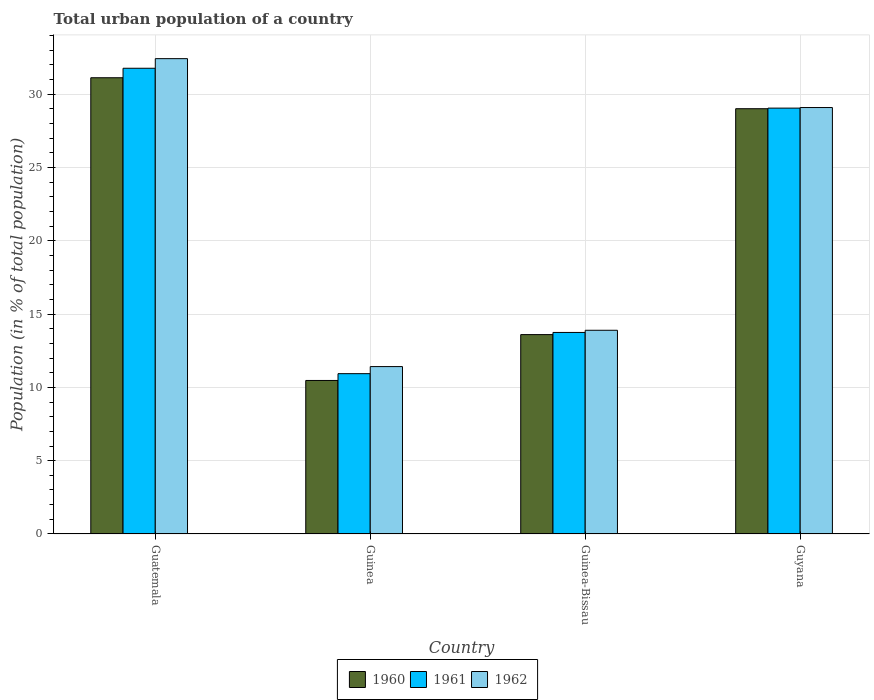How many different coloured bars are there?
Provide a short and direct response. 3. Are the number of bars on each tick of the X-axis equal?
Your response must be concise. Yes. How many bars are there on the 4th tick from the right?
Provide a short and direct response. 3. What is the label of the 3rd group of bars from the left?
Keep it short and to the point. Guinea-Bissau. What is the urban population in 1961 in Guinea?
Offer a very short reply. 10.94. Across all countries, what is the maximum urban population in 1960?
Offer a very short reply. 31.12. Across all countries, what is the minimum urban population in 1961?
Provide a succinct answer. 10.94. In which country was the urban population in 1962 maximum?
Your answer should be very brief. Guatemala. In which country was the urban population in 1962 minimum?
Your response must be concise. Guinea. What is the total urban population in 1962 in the graph?
Your answer should be compact. 86.83. What is the difference between the urban population in 1962 in Guatemala and that in Guinea-Bissau?
Ensure brevity in your answer.  18.53. What is the difference between the urban population in 1961 in Guatemala and the urban population in 1960 in Guinea?
Provide a short and direct response. 21.3. What is the average urban population in 1960 per country?
Give a very brief answer. 21.05. What is the difference between the urban population of/in 1960 and urban population of/in 1962 in Guatemala?
Ensure brevity in your answer.  -1.3. In how many countries, is the urban population in 1961 greater than 10 %?
Make the answer very short. 4. What is the ratio of the urban population in 1960 in Guinea to that in Guinea-Bissau?
Your response must be concise. 0.77. Is the urban population in 1961 in Guinea-Bissau less than that in Guyana?
Your response must be concise. Yes. Is the difference between the urban population in 1960 in Guatemala and Guinea-Bissau greater than the difference between the urban population in 1962 in Guatemala and Guinea-Bissau?
Offer a terse response. No. What is the difference between the highest and the second highest urban population in 1962?
Make the answer very short. 18.53. What is the difference between the highest and the lowest urban population in 1960?
Offer a very short reply. 20.65. What does the 3rd bar from the left in Guatemala represents?
Ensure brevity in your answer.  1962. How many bars are there?
Your answer should be compact. 12. What is the difference between two consecutive major ticks on the Y-axis?
Your answer should be compact. 5. Does the graph contain grids?
Your answer should be very brief. Yes. Where does the legend appear in the graph?
Offer a terse response. Bottom center. How many legend labels are there?
Your answer should be compact. 3. How are the legend labels stacked?
Give a very brief answer. Horizontal. What is the title of the graph?
Your answer should be compact. Total urban population of a country. Does "2004" appear as one of the legend labels in the graph?
Keep it short and to the point. No. What is the label or title of the X-axis?
Ensure brevity in your answer.  Country. What is the label or title of the Y-axis?
Give a very brief answer. Population (in % of total population). What is the Population (in % of total population) in 1960 in Guatemala?
Give a very brief answer. 31.12. What is the Population (in % of total population) in 1961 in Guatemala?
Keep it short and to the point. 31.77. What is the Population (in % of total population) of 1962 in Guatemala?
Make the answer very short. 32.42. What is the Population (in % of total population) of 1960 in Guinea?
Your answer should be very brief. 10.47. What is the Population (in % of total population) of 1961 in Guinea?
Offer a very short reply. 10.94. What is the Population (in % of total population) of 1962 in Guinea?
Offer a terse response. 11.42. What is the Population (in % of total population) in 1961 in Guinea-Bissau?
Provide a succinct answer. 13.75. What is the Population (in % of total population) in 1962 in Guinea-Bissau?
Your answer should be compact. 13.89. What is the Population (in % of total population) of 1960 in Guyana?
Your answer should be compact. 29.01. What is the Population (in % of total population) in 1961 in Guyana?
Provide a succinct answer. 29.05. What is the Population (in % of total population) in 1962 in Guyana?
Keep it short and to the point. 29.09. Across all countries, what is the maximum Population (in % of total population) in 1960?
Give a very brief answer. 31.12. Across all countries, what is the maximum Population (in % of total population) in 1961?
Your answer should be very brief. 31.77. Across all countries, what is the maximum Population (in % of total population) in 1962?
Provide a short and direct response. 32.42. Across all countries, what is the minimum Population (in % of total population) in 1960?
Ensure brevity in your answer.  10.47. Across all countries, what is the minimum Population (in % of total population) in 1961?
Your answer should be compact. 10.94. Across all countries, what is the minimum Population (in % of total population) of 1962?
Your answer should be compact. 11.42. What is the total Population (in % of total population) in 1960 in the graph?
Provide a short and direct response. 84.2. What is the total Population (in % of total population) in 1961 in the graph?
Keep it short and to the point. 85.5. What is the total Population (in % of total population) of 1962 in the graph?
Ensure brevity in your answer.  86.83. What is the difference between the Population (in % of total population) of 1960 in Guatemala and that in Guinea?
Offer a very short reply. 20.65. What is the difference between the Population (in % of total population) of 1961 in Guatemala and that in Guinea?
Keep it short and to the point. 20.83. What is the difference between the Population (in % of total population) in 1962 in Guatemala and that in Guinea?
Provide a succinct answer. 21.01. What is the difference between the Population (in % of total population) of 1960 in Guatemala and that in Guinea-Bissau?
Ensure brevity in your answer.  17.52. What is the difference between the Population (in % of total population) in 1961 in Guatemala and that in Guinea-Bissau?
Provide a succinct answer. 18.02. What is the difference between the Population (in % of total population) in 1962 in Guatemala and that in Guinea-Bissau?
Make the answer very short. 18.53. What is the difference between the Population (in % of total population) in 1960 in Guatemala and that in Guyana?
Provide a succinct answer. 2.11. What is the difference between the Population (in % of total population) of 1961 in Guatemala and that in Guyana?
Your response must be concise. 2.72. What is the difference between the Population (in % of total population) in 1962 in Guatemala and that in Guyana?
Provide a short and direct response. 3.33. What is the difference between the Population (in % of total population) in 1960 in Guinea and that in Guinea-Bissau?
Offer a very short reply. -3.13. What is the difference between the Population (in % of total population) in 1961 in Guinea and that in Guinea-Bissau?
Offer a very short reply. -2.81. What is the difference between the Population (in % of total population) of 1962 in Guinea and that in Guinea-Bissau?
Your answer should be compact. -2.48. What is the difference between the Population (in % of total population) of 1960 in Guinea and that in Guyana?
Keep it short and to the point. -18.54. What is the difference between the Population (in % of total population) of 1961 in Guinea and that in Guyana?
Offer a very short reply. -18.11. What is the difference between the Population (in % of total population) in 1962 in Guinea and that in Guyana?
Your answer should be very brief. -17.67. What is the difference between the Population (in % of total population) in 1960 in Guinea-Bissau and that in Guyana?
Offer a very short reply. -15.41. What is the difference between the Population (in % of total population) of 1961 in Guinea-Bissau and that in Guyana?
Your response must be concise. -15.3. What is the difference between the Population (in % of total population) in 1962 in Guinea-Bissau and that in Guyana?
Give a very brief answer. -15.19. What is the difference between the Population (in % of total population) of 1960 in Guatemala and the Population (in % of total population) of 1961 in Guinea?
Your answer should be compact. 20.18. What is the difference between the Population (in % of total population) in 1960 in Guatemala and the Population (in % of total population) in 1962 in Guinea?
Provide a succinct answer. 19.7. What is the difference between the Population (in % of total population) of 1961 in Guatemala and the Population (in % of total population) of 1962 in Guinea?
Keep it short and to the point. 20.35. What is the difference between the Population (in % of total population) of 1960 in Guatemala and the Population (in % of total population) of 1961 in Guinea-Bissau?
Provide a short and direct response. 17.37. What is the difference between the Population (in % of total population) of 1960 in Guatemala and the Population (in % of total population) of 1962 in Guinea-Bissau?
Offer a very short reply. 17.23. What is the difference between the Population (in % of total population) in 1961 in Guatemala and the Population (in % of total population) in 1962 in Guinea-Bissau?
Your answer should be compact. 17.87. What is the difference between the Population (in % of total population) of 1960 in Guatemala and the Population (in % of total population) of 1961 in Guyana?
Keep it short and to the point. 2.07. What is the difference between the Population (in % of total population) of 1960 in Guatemala and the Population (in % of total population) of 1962 in Guyana?
Your response must be concise. 2.03. What is the difference between the Population (in % of total population) of 1961 in Guatemala and the Population (in % of total population) of 1962 in Guyana?
Make the answer very short. 2.68. What is the difference between the Population (in % of total population) in 1960 in Guinea and the Population (in % of total population) in 1961 in Guinea-Bissau?
Make the answer very short. -3.27. What is the difference between the Population (in % of total population) in 1960 in Guinea and the Population (in % of total population) in 1962 in Guinea-Bissau?
Keep it short and to the point. -3.42. What is the difference between the Population (in % of total population) in 1961 in Guinea and the Population (in % of total population) in 1962 in Guinea-Bissau?
Your response must be concise. -2.96. What is the difference between the Population (in % of total population) of 1960 in Guinea and the Population (in % of total population) of 1961 in Guyana?
Make the answer very short. -18.58. What is the difference between the Population (in % of total population) of 1960 in Guinea and the Population (in % of total population) of 1962 in Guyana?
Offer a very short reply. -18.62. What is the difference between the Population (in % of total population) of 1961 in Guinea and the Population (in % of total population) of 1962 in Guyana?
Ensure brevity in your answer.  -18.15. What is the difference between the Population (in % of total population) in 1960 in Guinea-Bissau and the Population (in % of total population) in 1961 in Guyana?
Your answer should be compact. -15.45. What is the difference between the Population (in % of total population) in 1960 in Guinea-Bissau and the Population (in % of total population) in 1962 in Guyana?
Provide a succinct answer. -15.49. What is the difference between the Population (in % of total population) of 1961 in Guinea-Bissau and the Population (in % of total population) of 1962 in Guyana?
Keep it short and to the point. -15.34. What is the average Population (in % of total population) of 1960 per country?
Your answer should be very brief. 21.05. What is the average Population (in % of total population) of 1961 per country?
Offer a terse response. 21.38. What is the average Population (in % of total population) in 1962 per country?
Your answer should be compact. 21.71. What is the difference between the Population (in % of total population) of 1960 and Population (in % of total population) of 1961 in Guatemala?
Ensure brevity in your answer.  -0.65. What is the difference between the Population (in % of total population) of 1960 and Population (in % of total population) of 1962 in Guatemala?
Keep it short and to the point. -1.3. What is the difference between the Population (in % of total population) of 1961 and Population (in % of total population) of 1962 in Guatemala?
Offer a terse response. -0.66. What is the difference between the Population (in % of total population) of 1960 and Population (in % of total population) of 1961 in Guinea?
Make the answer very short. -0.46. What is the difference between the Population (in % of total population) in 1960 and Population (in % of total population) in 1962 in Guinea?
Keep it short and to the point. -0.95. What is the difference between the Population (in % of total population) in 1961 and Population (in % of total population) in 1962 in Guinea?
Your answer should be very brief. -0.48. What is the difference between the Population (in % of total population) in 1960 and Population (in % of total population) in 1961 in Guinea-Bissau?
Your answer should be compact. -0.15. What is the difference between the Population (in % of total population) of 1960 and Population (in % of total population) of 1962 in Guinea-Bissau?
Offer a terse response. -0.29. What is the difference between the Population (in % of total population) of 1961 and Population (in % of total population) of 1962 in Guinea-Bissau?
Ensure brevity in your answer.  -0.15. What is the difference between the Population (in % of total population) in 1960 and Population (in % of total population) in 1961 in Guyana?
Your answer should be compact. -0.04. What is the difference between the Population (in % of total population) in 1960 and Population (in % of total population) in 1962 in Guyana?
Offer a very short reply. -0.08. What is the difference between the Population (in % of total population) of 1961 and Population (in % of total population) of 1962 in Guyana?
Your answer should be very brief. -0.04. What is the ratio of the Population (in % of total population) of 1960 in Guatemala to that in Guinea?
Give a very brief answer. 2.97. What is the ratio of the Population (in % of total population) in 1961 in Guatemala to that in Guinea?
Your response must be concise. 2.9. What is the ratio of the Population (in % of total population) in 1962 in Guatemala to that in Guinea?
Make the answer very short. 2.84. What is the ratio of the Population (in % of total population) of 1960 in Guatemala to that in Guinea-Bissau?
Make the answer very short. 2.29. What is the ratio of the Population (in % of total population) in 1961 in Guatemala to that in Guinea-Bissau?
Provide a succinct answer. 2.31. What is the ratio of the Population (in % of total population) in 1962 in Guatemala to that in Guinea-Bissau?
Provide a succinct answer. 2.33. What is the ratio of the Population (in % of total population) of 1960 in Guatemala to that in Guyana?
Offer a very short reply. 1.07. What is the ratio of the Population (in % of total population) in 1961 in Guatemala to that in Guyana?
Ensure brevity in your answer.  1.09. What is the ratio of the Population (in % of total population) of 1962 in Guatemala to that in Guyana?
Ensure brevity in your answer.  1.11. What is the ratio of the Population (in % of total population) of 1960 in Guinea to that in Guinea-Bissau?
Make the answer very short. 0.77. What is the ratio of the Population (in % of total population) in 1961 in Guinea to that in Guinea-Bissau?
Keep it short and to the point. 0.8. What is the ratio of the Population (in % of total population) in 1962 in Guinea to that in Guinea-Bissau?
Your response must be concise. 0.82. What is the ratio of the Population (in % of total population) in 1960 in Guinea to that in Guyana?
Keep it short and to the point. 0.36. What is the ratio of the Population (in % of total population) of 1961 in Guinea to that in Guyana?
Keep it short and to the point. 0.38. What is the ratio of the Population (in % of total population) of 1962 in Guinea to that in Guyana?
Offer a terse response. 0.39. What is the ratio of the Population (in % of total population) in 1960 in Guinea-Bissau to that in Guyana?
Your answer should be compact. 0.47. What is the ratio of the Population (in % of total population) in 1961 in Guinea-Bissau to that in Guyana?
Offer a terse response. 0.47. What is the ratio of the Population (in % of total population) of 1962 in Guinea-Bissau to that in Guyana?
Your answer should be very brief. 0.48. What is the difference between the highest and the second highest Population (in % of total population) in 1960?
Provide a short and direct response. 2.11. What is the difference between the highest and the second highest Population (in % of total population) in 1961?
Your answer should be compact. 2.72. What is the difference between the highest and the second highest Population (in % of total population) of 1962?
Keep it short and to the point. 3.33. What is the difference between the highest and the lowest Population (in % of total population) of 1960?
Your answer should be very brief. 20.65. What is the difference between the highest and the lowest Population (in % of total population) of 1961?
Keep it short and to the point. 20.83. What is the difference between the highest and the lowest Population (in % of total population) of 1962?
Provide a short and direct response. 21.01. 